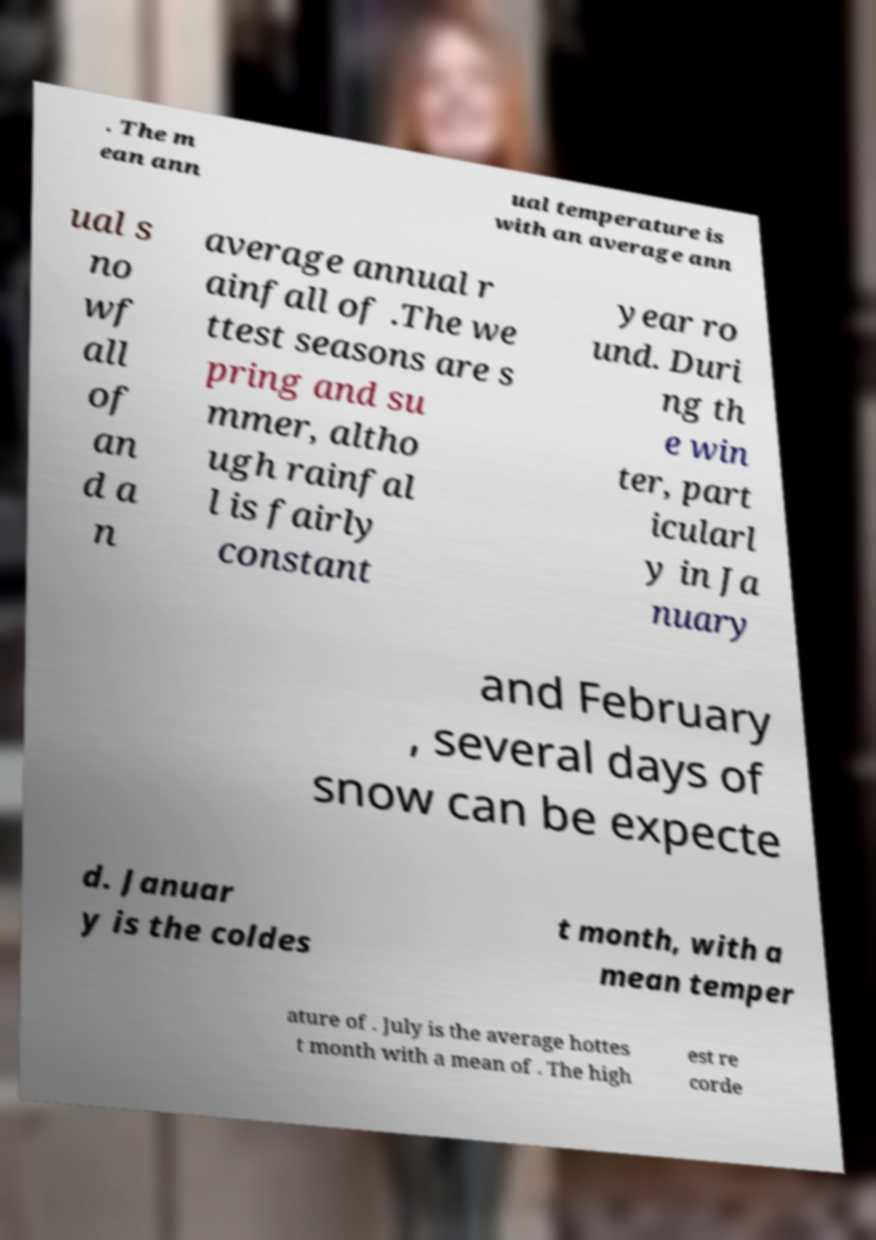Could you extract and type out the text from this image? . The m ean ann ual temperature is with an average ann ual s no wf all of an d a n average annual r ainfall of .The we ttest seasons are s pring and su mmer, altho ugh rainfal l is fairly constant year ro und. Duri ng th e win ter, part icularl y in Ja nuary and February , several days of snow can be expecte d. Januar y is the coldes t month, with a mean temper ature of . July is the average hottes t month with a mean of . The high est re corde 